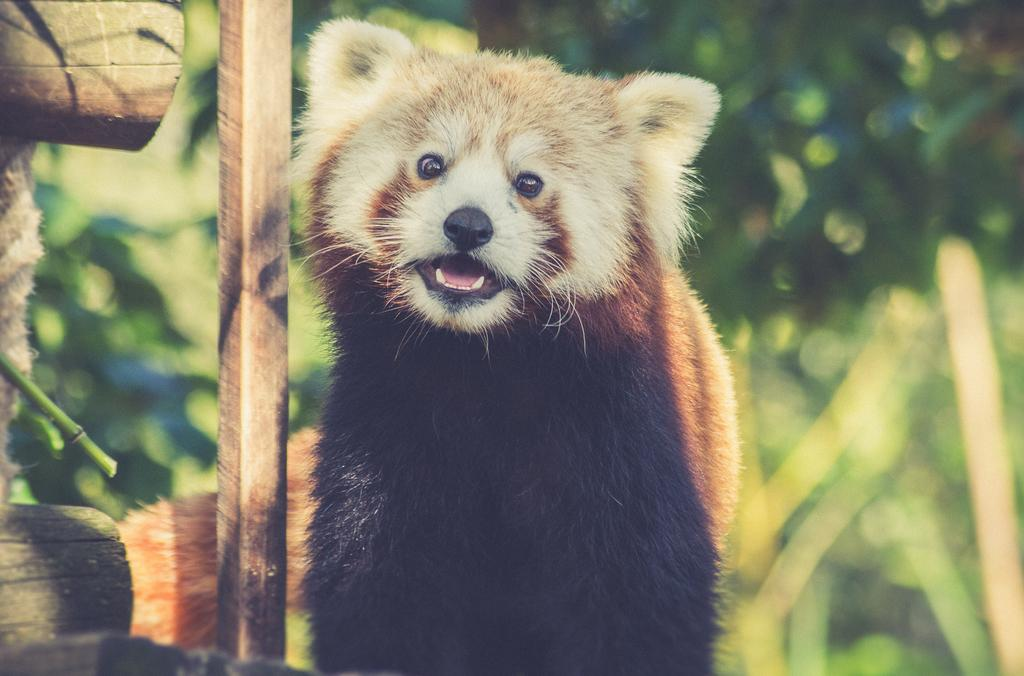What type of animal is in the image? The type of animal cannot be determined from the provided facts. What objects are on the left side of the image? There are trunks on the left side of the image. How would you describe the background of the image? The background of the image is blurred. What type of clover is growing on the trunks in the image? There is no clover present in the image; the only visible objects are the trunks. 